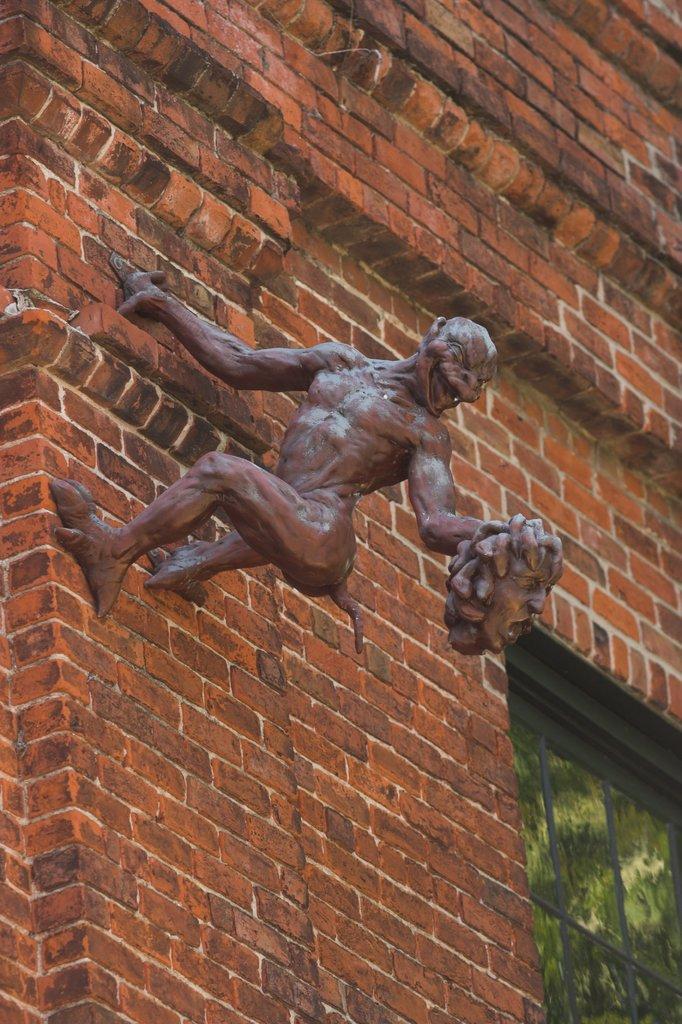Could you give a brief overview of what you see in this image? In this picture we can see a statue in the middle, on the right side there is a window, we can see a brick wall in the background. 